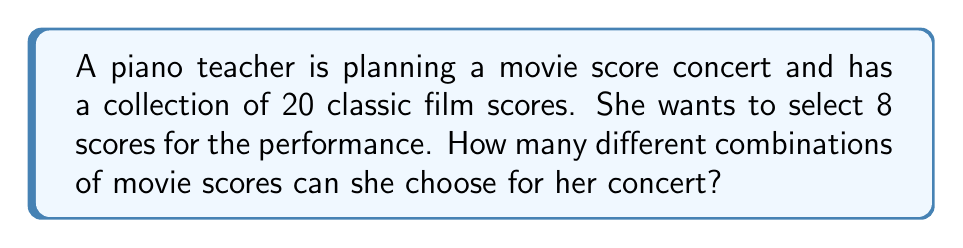Teach me how to tackle this problem. Let's approach this step-by-step:

1) This is a combination problem. We are selecting 8 scores from a set of 20, where the order doesn't matter.

2) The formula for combinations is:

   $$C(n,r) = \frac{n!}{r!(n-r)!}$$

   where $n$ is the total number of items to choose from, and $r$ is the number of items being chosen.

3) In this case, $n = 20$ (total number of scores) and $r = 8$ (number of scores to be selected).

4) Substituting these values into our formula:

   $$C(20,8) = \frac{20!}{8!(20-8)!} = \frac{20!}{8!12!}$$

5) Expanding this:
   
   $$\frac{20 \times 19 \times 18 \times 17 \times 16 \times 15 \times 14 \times 13 \times 12!}{(8 \times 7 \times 6 \times 5 \times 4 \times 3 \times 2 \times 1) \times 12!}$$

6) The 12! cancels out in the numerator and denominator:

   $$\frac{20 \times 19 \times 18 \times 17 \times 16 \times 15 \times 14 \times 13}{8 \times 7 \times 6 \times 5 \times 4 \times 3 \times 2 \times 1}$$

7) Calculating this:

   $$\frac{125,970,240}{40,320} = 3,124,550$$

Therefore, there are 3,124,550 different ways to select 8 scores from a collection of 20.
Answer: 3,124,550 